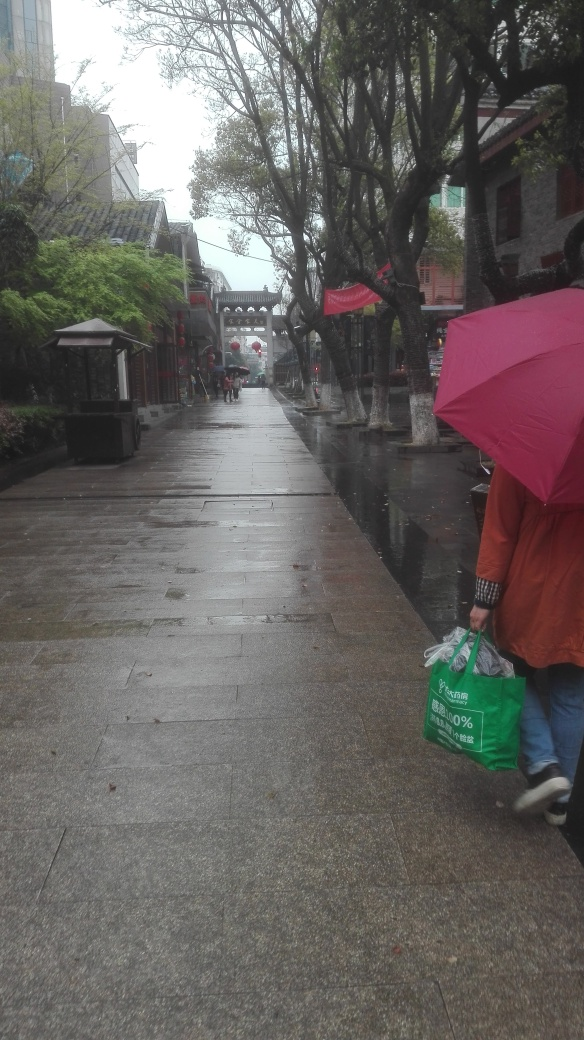Can you tell me about the weather conditions in this image? The image shows a rainy day, as evidenced by the wet surfaces, the umbrellas being used by the pedestrians, and the overcast sky. The lack of harsh shadows suggests that the photo was taken during an overcast day, where the soft diffused light is consistent with such weather conditions. How would you describe the mood this weather creates? The rainy setting combined with the gloomy sky imbues the scene with a somber, tranquil mood. The quiet streets and subdued colors also suggest a serene, if not slightly melancholic atmosphere, where the hustle of a sunny day is replaced by a more reflective, slower-paced environment. 